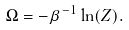<formula> <loc_0><loc_0><loc_500><loc_500>\Omega = - \beta ^ { - 1 } \ln ( Z ) .</formula> 